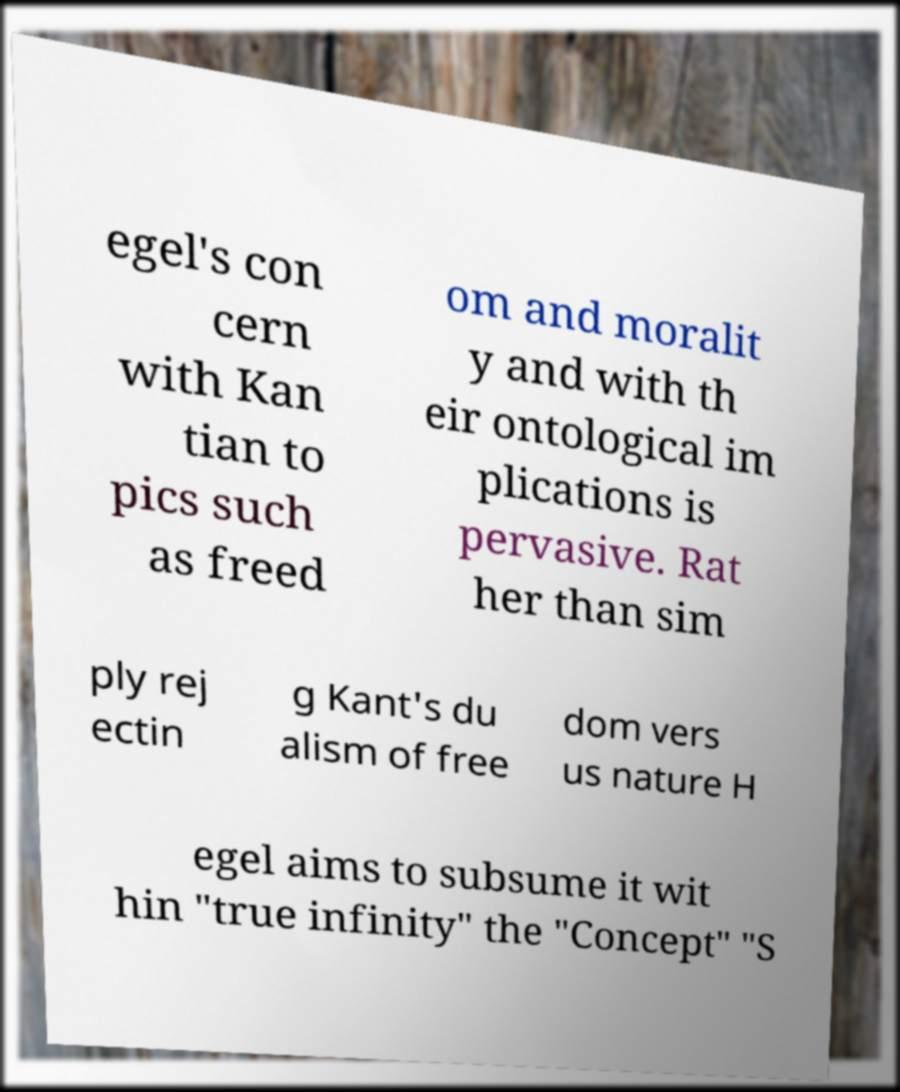Can you accurately transcribe the text from the provided image for me? egel's con cern with Kan tian to pics such as freed om and moralit y and with th eir ontological im plications is pervasive. Rat her than sim ply rej ectin g Kant's du alism of free dom vers us nature H egel aims to subsume it wit hin "true infinity" the "Concept" "S 